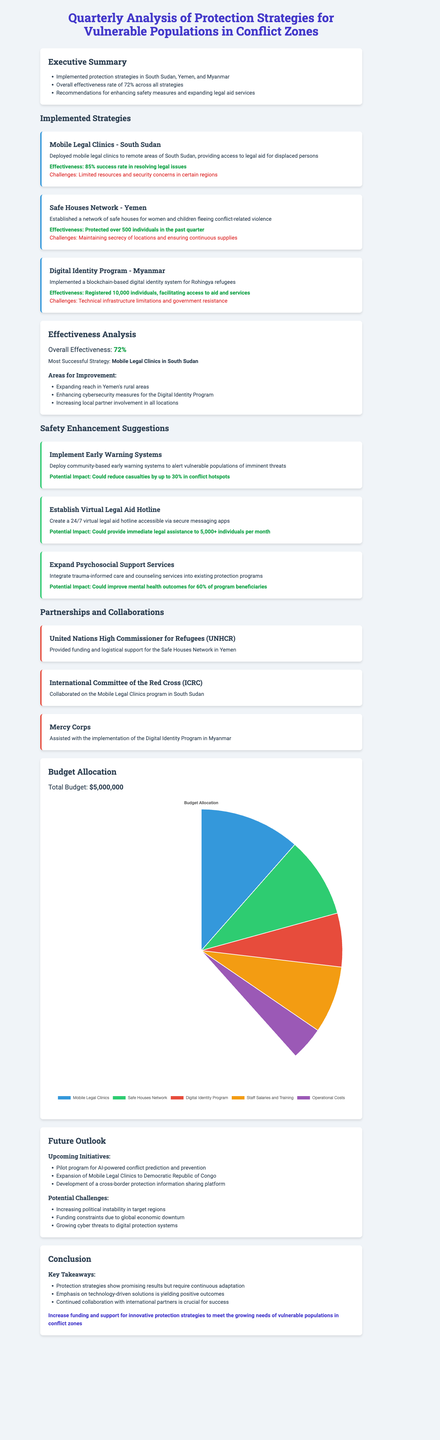What is the overall effectiveness rate of the protection strategies? The overall effectiveness rate is specifically stated in the effectiveness analysis section of the report.
Answer: 72% Which strategy had the highest success rate? This information can be found in the effectiveness analysis section where the most successful strategy is highlighted.
Answer: Mobile Legal Clinics in South Sudan How many individuals were registered in the Digital Identity Program in Myanmar? The report specifies the number of individuals registered in the Digital Identity Program.
Answer: 10,000 individuals What conflict zone has the Safe Houses Network been implemented in? The location of the Safe Houses Network is mentioned in the description of the implemented strategies.
Answer: Yemen What is one of the areas for improvement mentioned in the effectiveness analysis? The report lists specific areas for improvement that are discussed in the effectiveness analysis.
Answer: Expanding reach in Yemen's rural areas What is the total budget allocated for the protection strategies? The total budget is explicitly stated in the budget allocation section of the report.
Answer: $5,000,000 What potential impact could the establishment of a virtual legal aid hotline have? The report discusses the potential impact of the suggestion for a virtual legal aid hotline.
Answer: Could provide immediate legal assistance to 5,000+ individuals per month What organization provided funding for the Safe Houses Network? The partnerships and collaborations section of the report lists organizations and their contributions.
Answer: United Nations High Commissioner for Refugees (UNHCR) What upcoming initiative is planned for the future according to the report? Future initiatives are listed in the future outlook section of the report.
Answer: Pilot program for AI-powered conflict prediction and prevention 